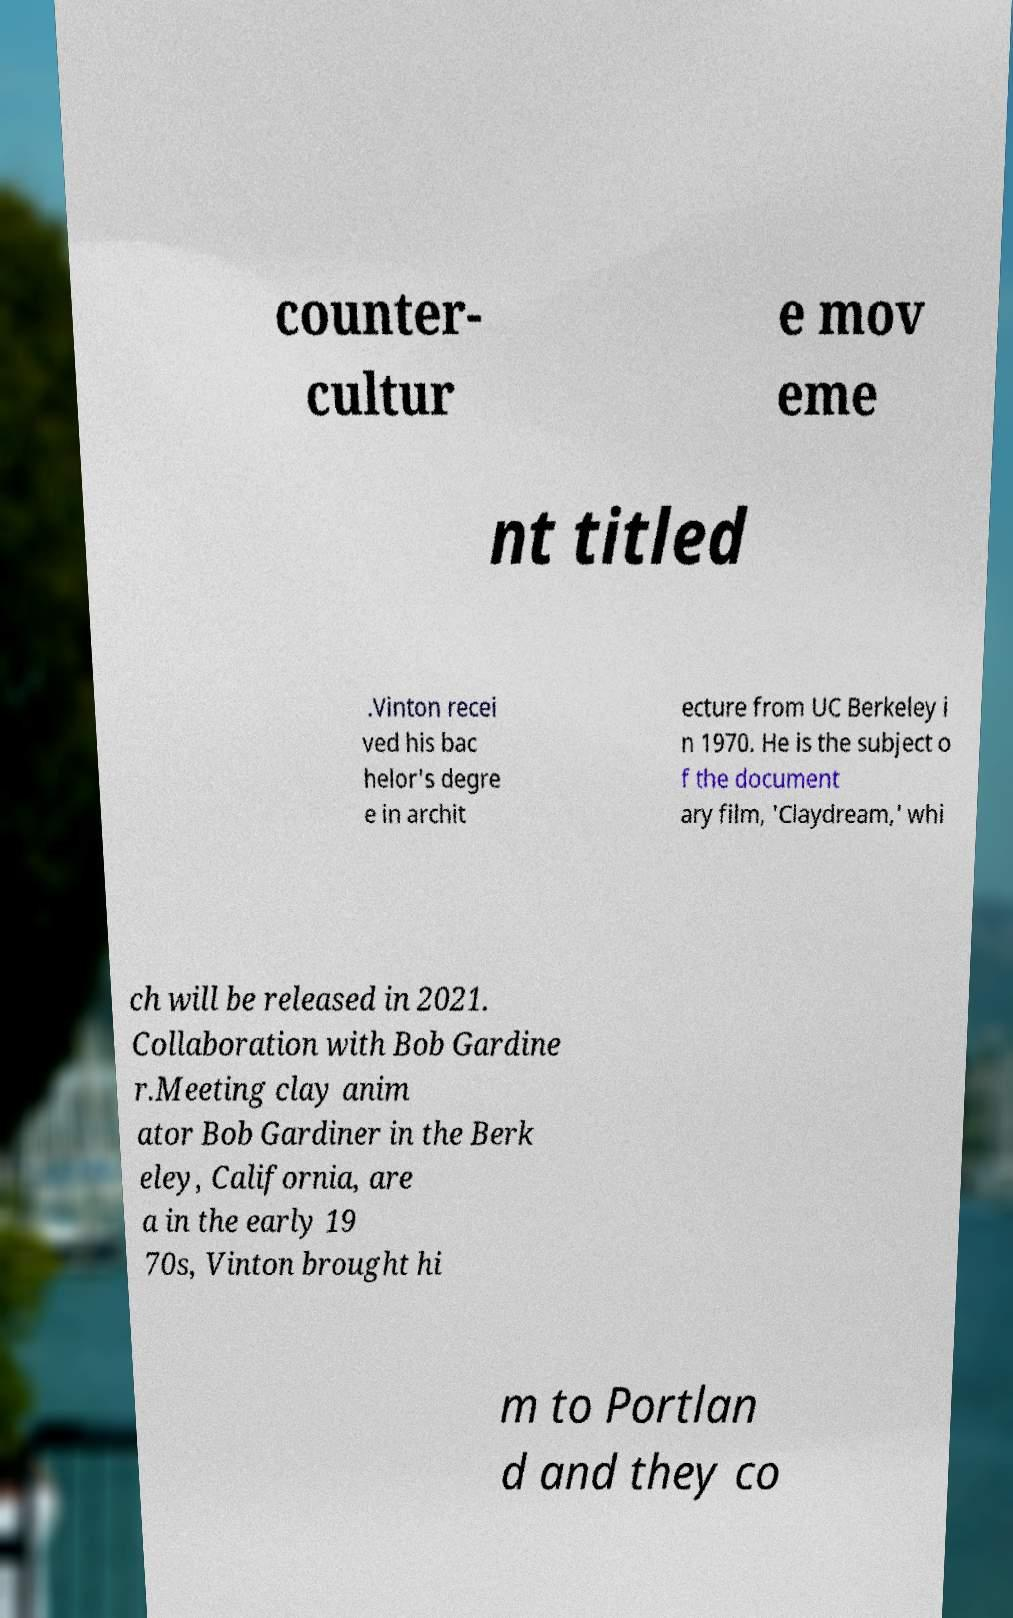There's text embedded in this image that I need extracted. Can you transcribe it verbatim? counter- cultur e mov eme nt titled .Vinton recei ved his bac helor's degre e in archit ecture from UC Berkeley i n 1970. He is the subject o f the document ary film, 'Claydream,' whi ch will be released in 2021. Collaboration with Bob Gardine r.Meeting clay anim ator Bob Gardiner in the Berk eley, California, are a in the early 19 70s, Vinton brought hi m to Portlan d and they co 